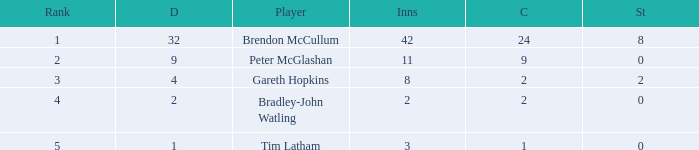How many dismissals did the player Peter McGlashan have? 9.0. 